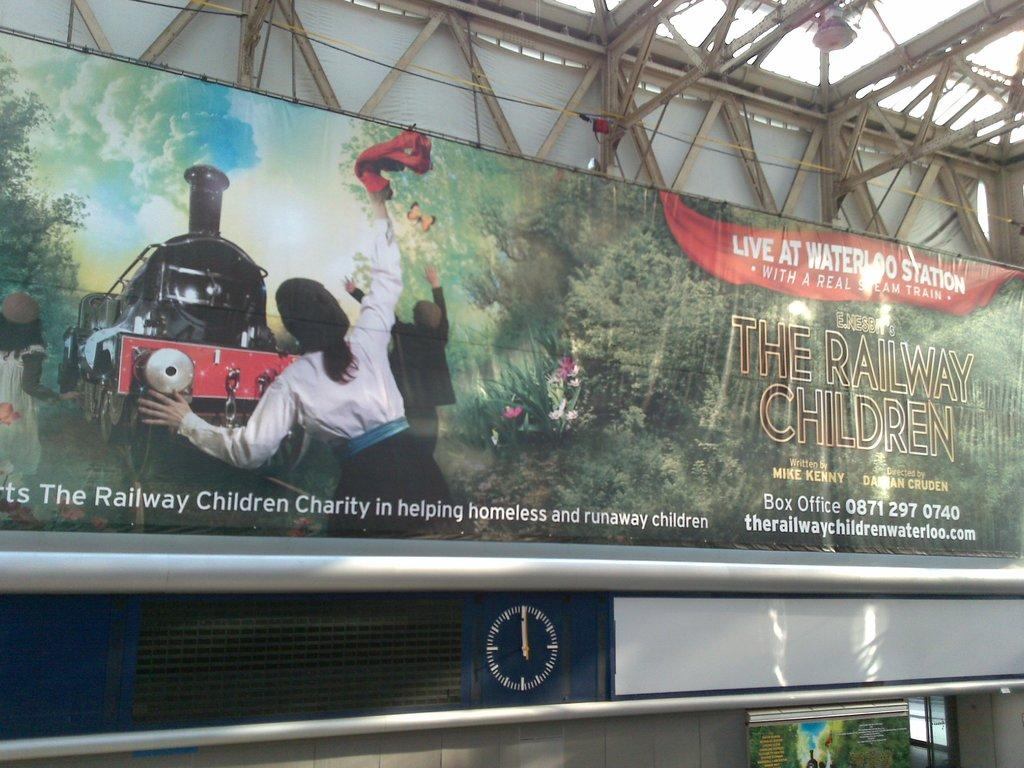<image>
Create a compact narrative representing the image presented. An advertisement for The Railway Children playing at waterloo station. 